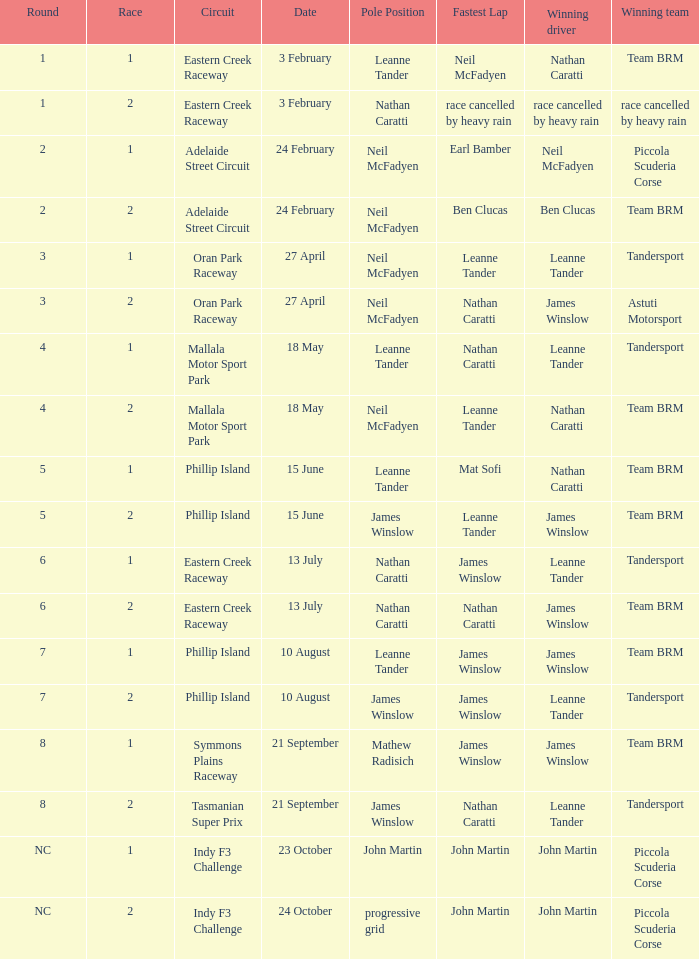Write the full table. {'header': ['Round', 'Race', 'Circuit', 'Date', 'Pole Position', 'Fastest Lap', 'Winning driver', 'Winning team'], 'rows': [['1', '1', 'Eastern Creek Raceway', '3 February', 'Leanne Tander', 'Neil McFadyen', 'Nathan Caratti', 'Team BRM'], ['1', '2', 'Eastern Creek Raceway', '3 February', 'Nathan Caratti', 'race cancelled by heavy rain', 'race cancelled by heavy rain', 'race cancelled by heavy rain'], ['2', '1', 'Adelaide Street Circuit', '24 February', 'Neil McFadyen', 'Earl Bamber', 'Neil McFadyen', 'Piccola Scuderia Corse'], ['2', '2', 'Adelaide Street Circuit', '24 February', 'Neil McFadyen', 'Ben Clucas', 'Ben Clucas', 'Team BRM'], ['3', '1', 'Oran Park Raceway', '27 April', 'Neil McFadyen', 'Leanne Tander', 'Leanne Tander', 'Tandersport'], ['3', '2', 'Oran Park Raceway', '27 April', 'Neil McFadyen', 'Nathan Caratti', 'James Winslow', 'Astuti Motorsport'], ['4', '1', 'Mallala Motor Sport Park', '18 May', 'Leanne Tander', 'Nathan Caratti', 'Leanne Tander', 'Tandersport'], ['4', '2', 'Mallala Motor Sport Park', '18 May', 'Neil McFadyen', 'Leanne Tander', 'Nathan Caratti', 'Team BRM'], ['5', '1', 'Phillip Island', '15 June', 'Leanne Tander', 'Mat Sofi', 'Nathan Caratti', 'Team BRM'], ['5', '2', 'Phillip Island', '15 June', 'James Winslow', 'Leanne Tander', 'James Winslow', 'Team BRM'], ['6', '1', 'Eastern Creek Raceway', '13 July', 'Nathan Caratti', 'James Winslow', 'Leanne Tander', 'Tandersport'], ['6', '2', 'Eastern Creek Raceway', '13 July', 'Nathan Caratti', 'Nathan Caratti', 'James Winslow', 'Team BRM'], ['7', '1', 'Phillip Island', '10 August', 'Leanne Tander', 'James Winslow', 'James Winslow', 'Team BRM'], ['7', '2', 'Phillip Island', '10 August', 'James Winslow', 'James Winslow', 'Leanne Tander', 'Tandersport'], ['8', '1', 'Symmons Plains Raceway', '21 September', 'Mathew Radisich', 'James Winslow', 'James Winslow', 'Team BRM'], ['8', '2', 'Tasmanian Super Prix', '21 September', 'James Winslow', 'Nathan Caratti', 'Leanne Tander', 'Tandersport'], ['NC', '1', 'Indy F3 Challenge', '23 October', 'John Martin', 'John Martin', 'John Martin', 'Piccola Scuderia Corse'], ['NC', '2', 'Indy F3 Challenge', '24 October', 'progressive grid', 'John Martin', 'John Martin', 'Piccola Scuderia Corse']]} Which race number featured john martin in the pole position within the indy f3 challenge circuit? 1.0. 